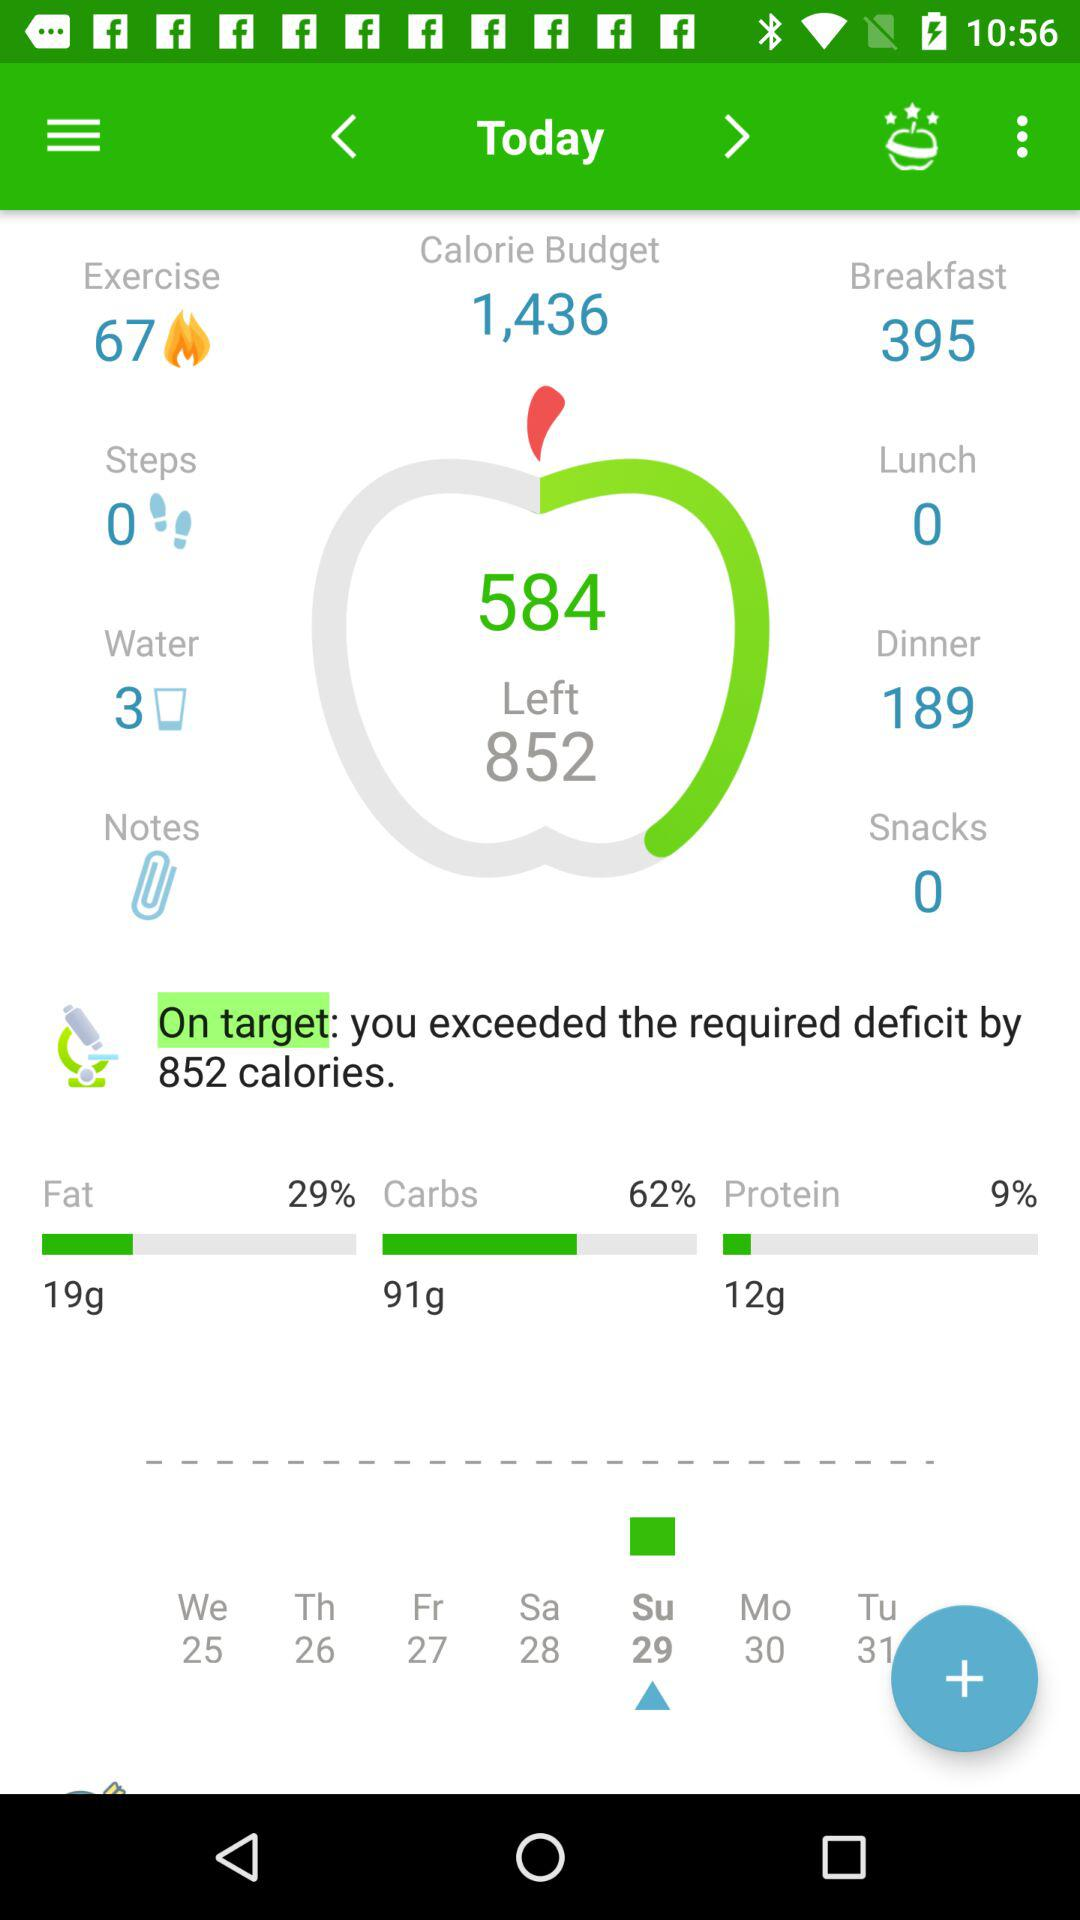What is the percentage of protein? The percentage of protein is 9. 